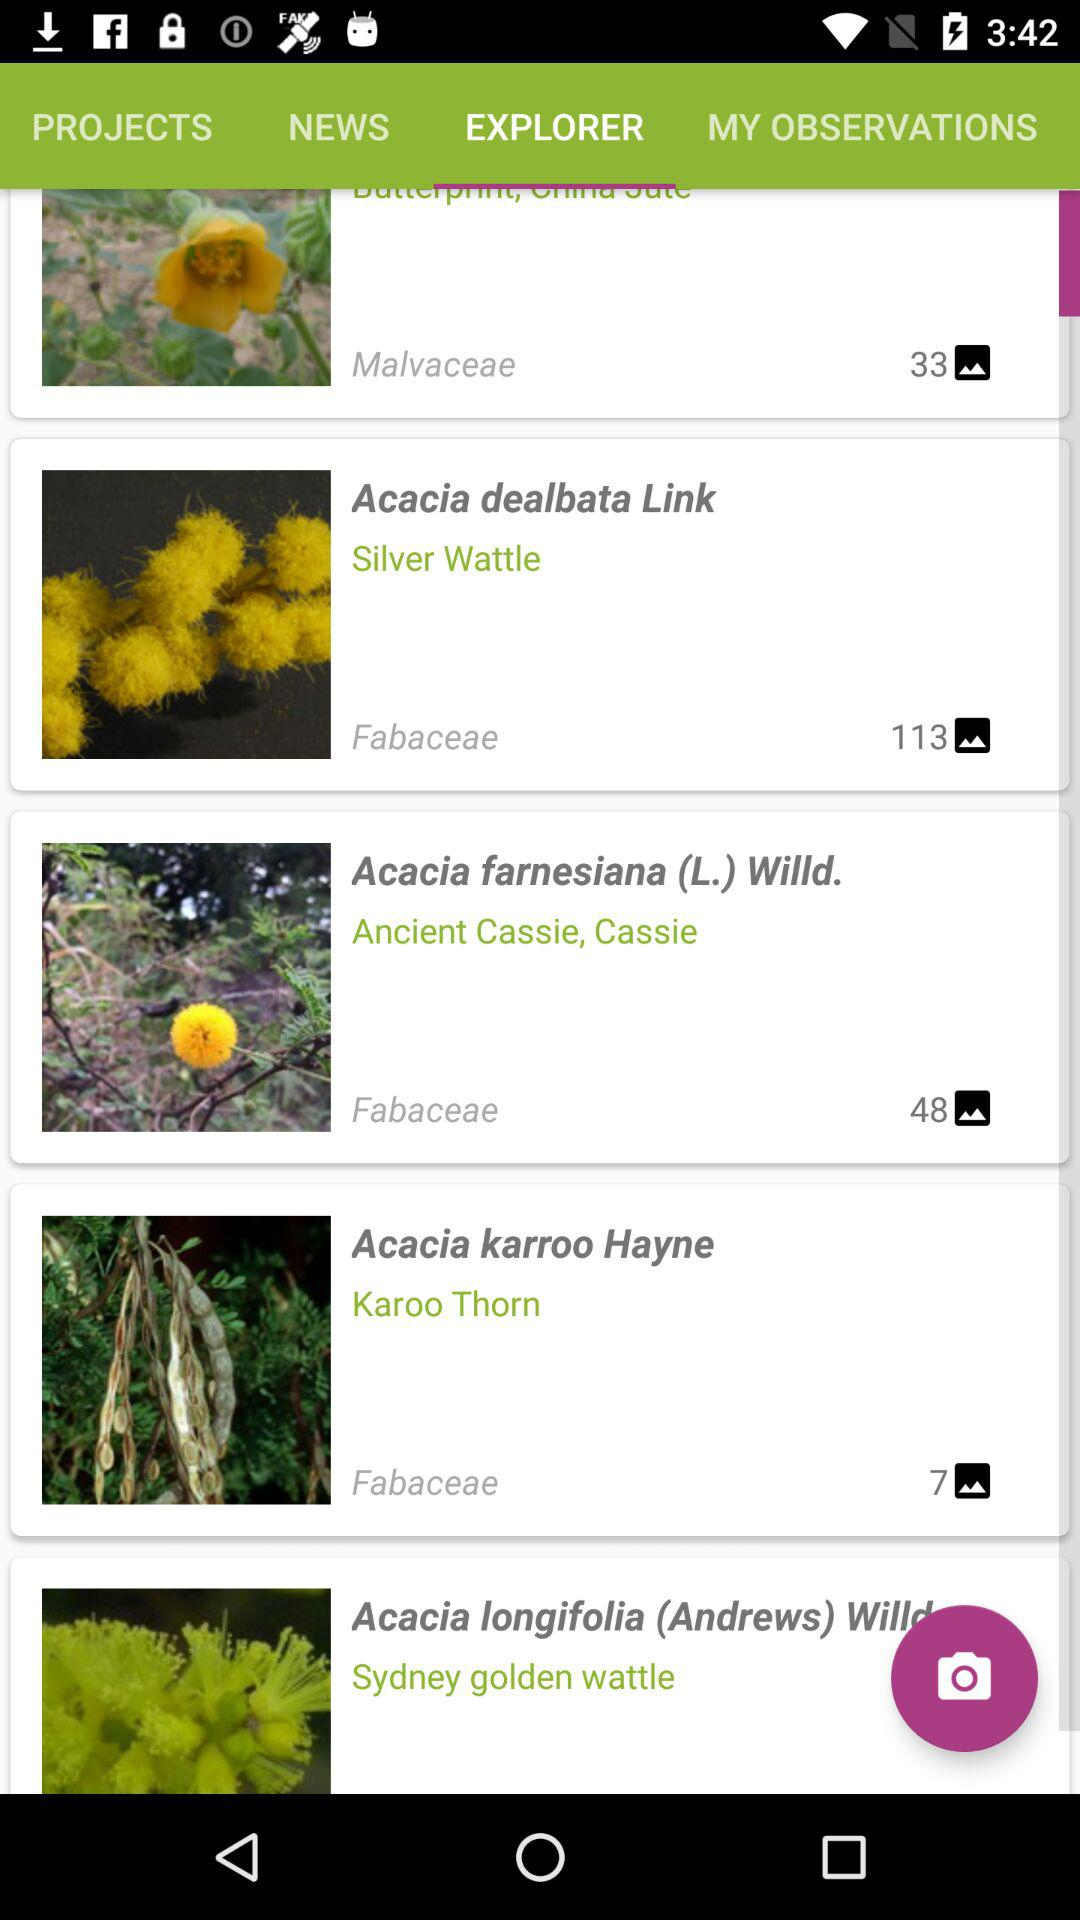What is the selected tab? The selected tab is Explorer. 